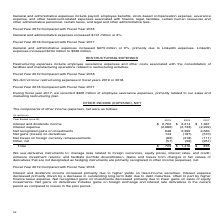According to Microsoft Corporation's financial document, What does the company use derivative instruments for? manage risks related to foreign currencies, equity prices, interest rates, and credit; enhance investment returns; and facilitate portfolio diversification.. The document states: "We use derivative instruments to: manage risks related to foreign currencies, equity prices, interest rates, and credit; enhance investment returns; a..." Also, Why did interest and dividends income change from 2018 to 2019? Interest and dividends income increased primarily due to higher yields on fixed-income securities.. The document states: "Interest and dividends income increased primarily due to higher yields on fixed-income securities. Interest expense decreased primarily driven by a de..." Also, Why did interest and dividends income increase from $1,387 million in 2017 to $2,214 million in 2018? Based on the financial document, the answer is Dividends and interest income increased primarily due to higher average portfolio balances and yields on fixed-income securities.. Also, can you calculate: What is the average interest and dividend income for the 3 year period from 2017 to 2019? To answer this question, I need to perform calculations using the financial data. The calculation is: (2,762+2,214+1,387)/3, which equals 2121 (in millions). This is based on the information: "Interest and dividends income $ 2,762 $ 2,214 $ 1,387 Interest and dividends income $ 2,762 $ 2,214 $ 1,387 Interest and dividends income $ 2,762 $ 2,214 $ 1,387..." The key data points involved are: 1,387, 2,214, 2,762. Also, can you calculate: What is the average total income from 2017 to 2019? To answer this question, I need to perform calculations using the financial data. The calculation is: (729+1,416+876)/3, which equals 1007 (in millions). This is based on the information: "Total $ 729 $ 1,416 $ 876 Total $ 729 $ 1,416 $ 876 Total $ 729 $ 1,416 $ 876..." The key data points involved are: 1,416, 729, 876. Also, can you calculate: What was the % change in interest and dividends income from 2018 to 2019? To answer this question, I need to perform calculations using the financial data. The calculation is: (2,762-2,214)/2,214, which equals 24.75 (percentage). This is based on the information: "Interest and dividends income $ 2,762 $ 2,214 $ 1,387 Interest and dividends income $ 2,762 $ 2,214 $ 1,387..." The key data points involved are: 2,214, 2,762. 